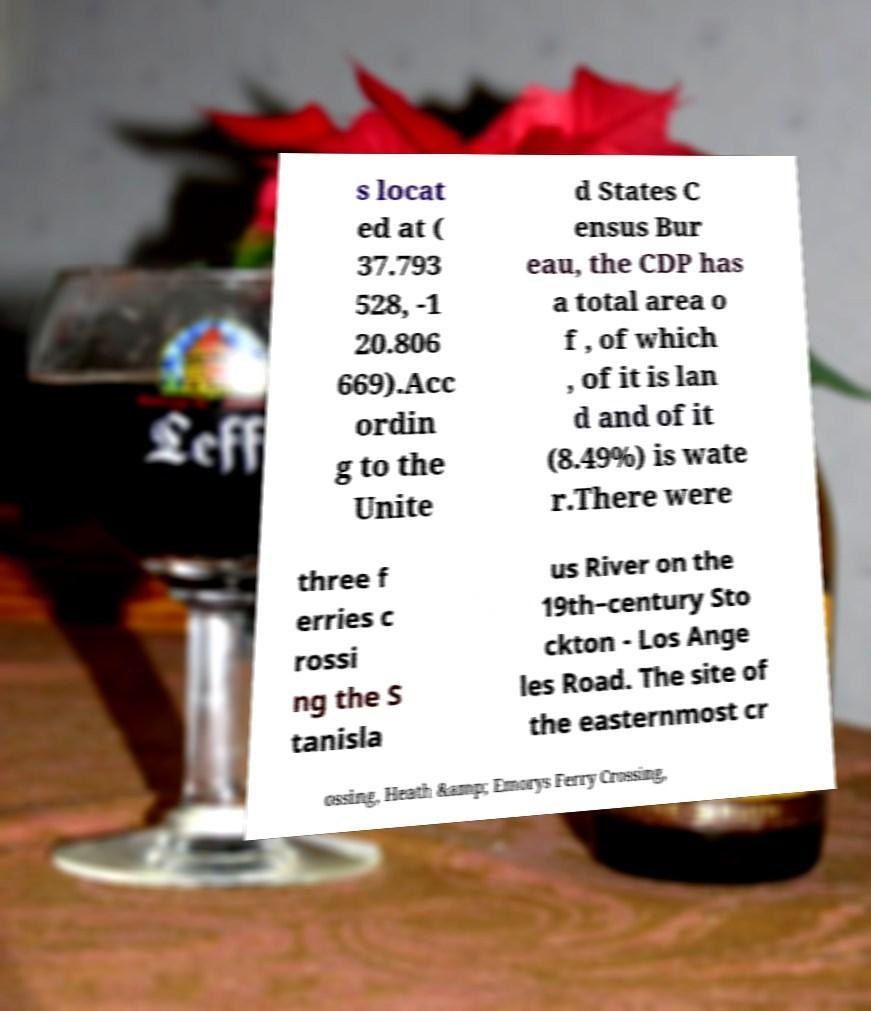Please identify and transcribe the text found in this image. s locat ed at ( 37.793 528, -1 20.806 669).Acc ordin g to the Unite d States C ensus Bur eau, the CDP has a total area o f , of which , of it is lan d and of it (8.49%) is wate r.There were three f erries c rossi ng the S tanisla us River on the 19th−century Sto ckton - Los Ange les Road. The site of the easternmost cr ossing, Heath &amp; Emorys Ferry Crossing, 